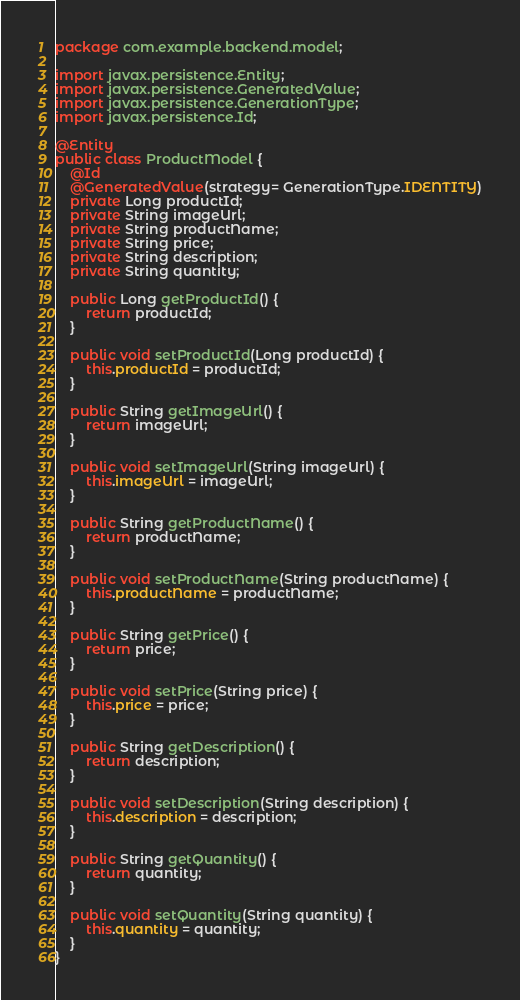Convert code to text. <code><loc_0><loc_0><loc_500><loc_500><_Java_>package com.example.backend.model;

import javax.persistence.Entity;
import javax.persistence.GeneratedValue;
import javax.persistence.GenerationType;
import javax.persistence.Id;

@Entity
public class ProductModel {
    @Id
    @GeneratedValue(strategy= GenerationType.IDENTITY)
    private Long productId;
    private String imageUrl;
    private String productName;
    private String price;
    private String description;
    private String quantity;

    public Long getProductId() {
        return productId;
    }

    public void setProductId(Long productId) {
        this.productId = productId;
    }

    public String getImageUrl() {
        return imageUrl;
    }

    public void setImageUrl(String imageUrl) {
        this.imageUrl = imageUrl;
    }

    public String getProductName() {
        return productName;
    }

    public void setProductName(String productName) {
        this.productName = productName;
    }

    public String getPrice() {
        return price;
    }

    public void setPrice(String price) {
        this.price = price;
    }

    public String getDescription() {
        return description;
    }

    public void setDescription(String description) {
        this.description = description;
    }

    public String getQuantity() {
        return quantity;
    }

    public void setQuantity(String quantity) {
        this.quantity = quantity;
    }
}
</code> 